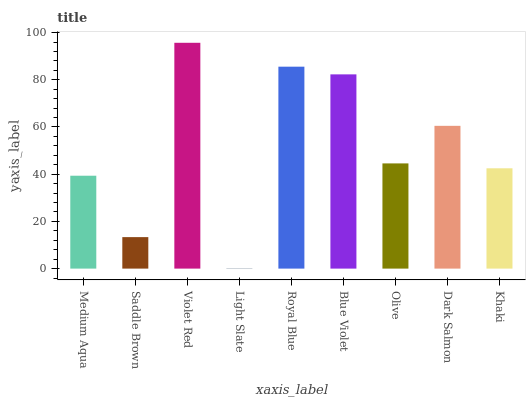Is Light Slate the minimum?
Answer yes or no. Yes. Is Violet Red the maximum?
Answer yes or no. Yes. Is Saddle Brown the minimum?
Answer yes or no. No. Is Saddle Brown the maximum?
Answer yes or no. No. Is Medium Aqua greater than Saddle Brown?
Answer yes or no. Yes. Is Saddle Brown less than Medium Aqua?
Answer yes or no. Yes. Is Saddle Brown greater than Medium Aqua?
Answer yes or no. No. Is Medium Aqua less than Saddle Brown?
Answer yes or no. No. Is Olive the high median?
Answer yes or no. Yes. Is Olive the low median?
Answer yes or no. Yes. Is Medium Aqua the high median?
Answer yes or no. No. Is Royal Blue the low median?
Answer yes or no. No. 